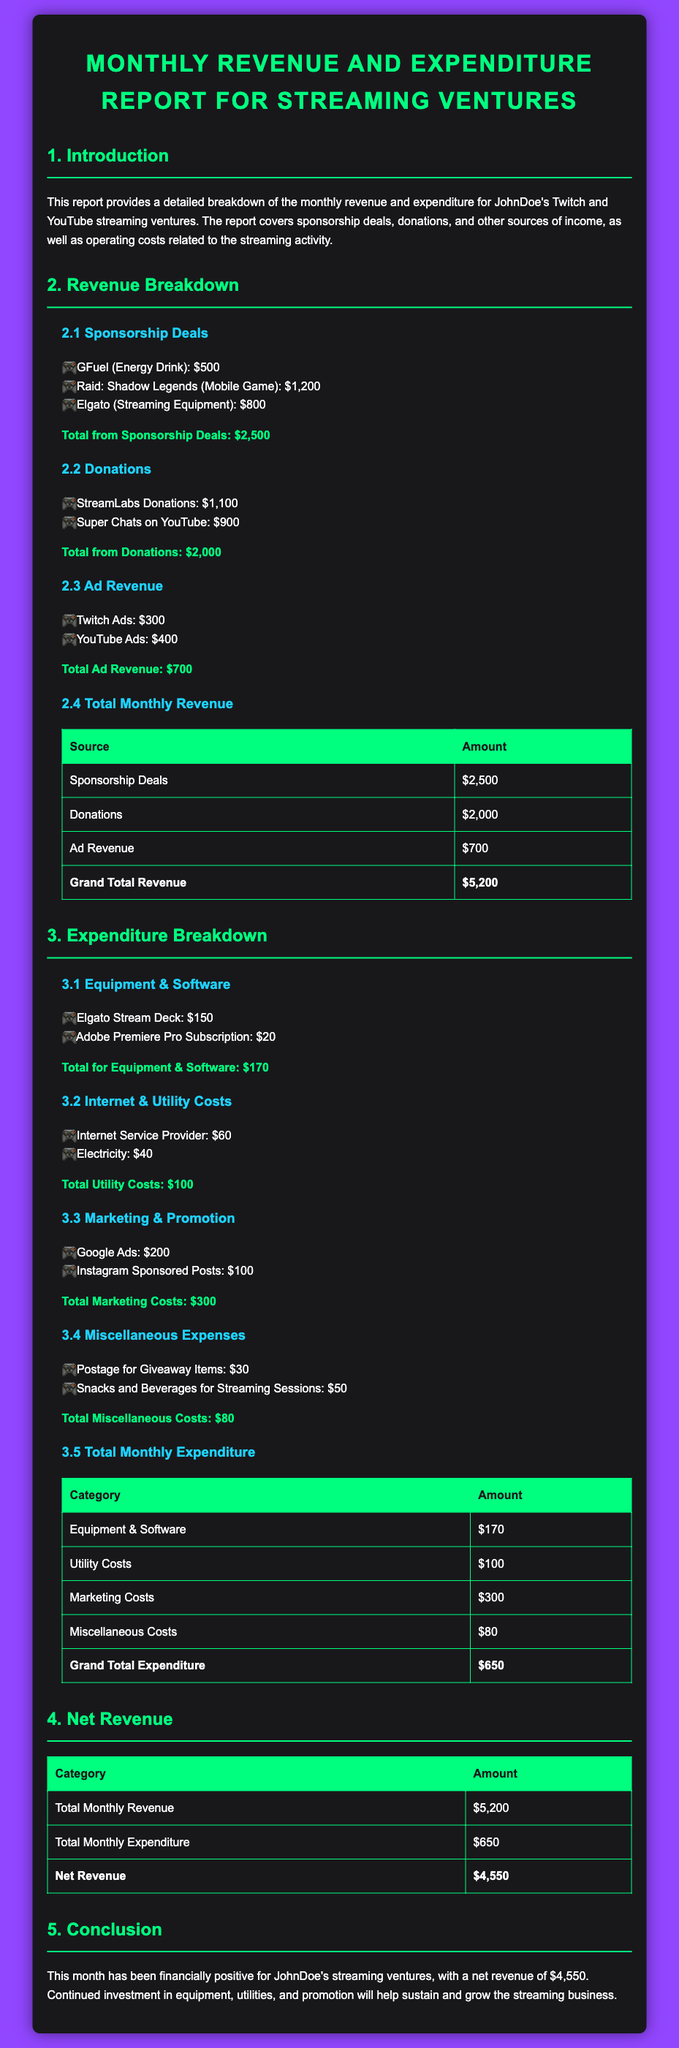What is the total from sponsorship deals? The total from sponsorship deals is calculated by adding the amounts listed for each deal: $500 + $1200 + $800 = $2500.
Answer: $2500 What is the total monthly revenue? The total monthly revenue is the sum of revenue sources: Sponsorship Deals ($2500) + Donations ($2000) + Ad Revenue ($700) = $5200.
Answer: $5200 What is the total for miscellaneous costs? The total for miscellaneous costs is the sum of the listed expenses: $30 + $50 = $80.
Answer: $80 What is the expenditure for marketing costs? The expenditure for marketing costs includes: Google Ads ($200) + Instagram Sponsored Posts ($100) = $300.
Answer: $300 What is the net revenue? The net revenue is calculated by subtracting total monthly expenditure ($650) from total monthly revenue ($5200): $5200 - $650 = $4550.
Answer: $4550 What is the amount received from StreamLabs donations? The amount received from StreamLabs donations is listed directly in the document as $1100.
Answer: $1100 How much was spent on the Adobe Premiere Pro subscription? The expenditure on the Adobe Premiere Pro subscription is specifically stated as $20.
Answer: $20 What is the total amount spent on equipment and software? The total amount spent on equipment and software is the sum of the listed items: $150 + $20 = $170.
Answer: $170 Who is the subject of the report? The subject of the report is JohnDoe, who manages the streaming ventures discussed.
Answer: JohnDoe 